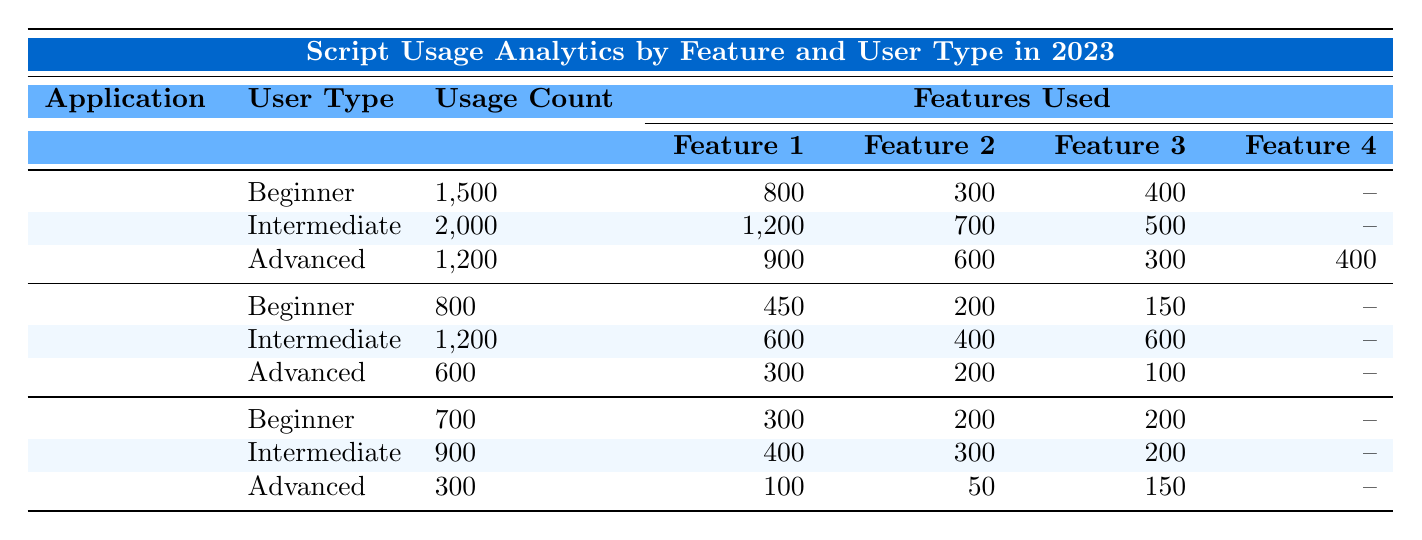What is the total usage count for Google Sheets in 2023? To find the total usage count for Google Sheets, add the usage counts for all user types: Beginner (1500) + Intermediate (2000) + Advanced (1200) = 4700.
Answer: 4700 Which feature was the most used by Intermediate users of Google Sheets? The most used feature by Intermediate users can be identified by comparing the feature usage numbers: Automated Data Entry (1200), Custom Functions (700), and Google Calendar Integration (500). The highest value is 1200 for Automated Data Entry.
Answer: Automated Data Entry Is there any feature used by Advanced users of Google Docs that was not used by Beginners? We look at the features used by Advanced users: Document Templates (300), Commenting Scripts (200), and Automated Summary Generation (100). Beginners use Document Templates (450) and Commenting Scripts (200), but do not use Automated Summary Generation, confirming it is unique to Advanced users.
Answer: Yes What is the average usage count of all user types across Google Forms? To find the average, first sum the usage counts: Beginner (700) + Intermediate (900) + Advanced (300) = 1900. There are three user types, so the average usage count is 1900 / 3 = 633.33.
Answer: 633.33 Which application has the highest usage count for Beginner users? To determine the application with the highest usage count for Beginners, compare the totals: Google Sheets (1500), Google Docs (800), Google Forms (700). Google Sheets has the highest with 1500.
Answer: Google Sheets How many features were used by Advanced users of Google Sheets? The Advanced users of Google Sheets utilized four features: Automated Data Entry, Custom Functions, Dashboard Communication, and API Interactions.
Answer: Four features What is the difference in usage count between Intermediate users of Google Sheets and Google Docs? First, identify the usage counts: Intermediate users of Google Sheets (2000) and Google Docs (1200). The difference is 2000 - 1200 = 800.
Answer: 800 Did Advanced users of Google Forms use more features than Intermediate users? Advanced users of Google Forms used three features: Form Validation Scripts, Response Notifications, and Integration with Google Sheets, while Intermediate users used three as well: Form Validation Scripts, Response Notifications, and Post-Processing Scripts. Thus, both used an equal number of features.
Answer: No 